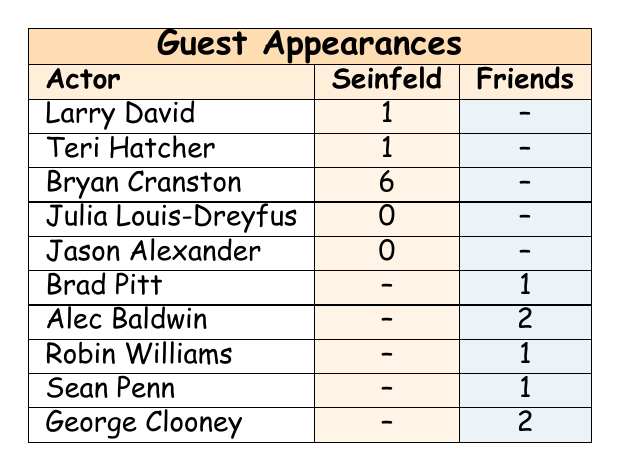What is the total number of guest appearances by Bryan Cranston in "Seinfeld"? Bryan Cranston is listed under the "Seinfeld" column with a total of 6 episodes. The only number next to his name indicates how many episodes he appeared in.
Answer: 6 How many guest appearances did Larry David make in "Seinfeld"? Larry David is also found in the "Seinfeld" column, where it states he appeared in 1 episode.
Answer: 1 Did any actor appear in both "Seinfeld" and "Friends"? By looking at the table, none of the actors listed appear in both columns. The "Seinfeld" actors and the "Friends" actors are distinct.
Answer: No Which show had more guest appearances overall? To determine this, we add up the guest appearances for each show. "Seinfeld" has 6 + 1 + 1 + 0 + 0 = 9 episodes. "Friends" totals 1 + 2 + 1 + 1 + 2 = 7 episodes. Comparing the totals, "Seinfeld" has more guest appearances.
Answer: Seinfeld What is the average number of guest appearances for actors in "Friends"? The total guest appearances in "Friends" is 1 + 2 + 1 + 1 + 2 = 7. There are 5 different actors, so the average is calculated by dividing the total by the number of actors: 7 / 5 = 1.4.
Answer: 1.4 Who had the most guest appearances in "Friends"? Looking through the "Friends" column, Alec Baldwin has 2 appearances, which is more than any other actor listed there.
Answer: Alec Baldwin Is it true that Julia Louis-Dreyfus had guest appearances in "Friends"? The table shows Julia Louis-Dreyfus under "Seinfeld" with 0 episodes and does not mention her under "Friends," meaning she did not appear in it.
Answer: No What is the sum of guest appearances between both shows? The total from "Seinfeld" is 6 + 1 + 1 + 0 + 0 = 9, and for "Friends," it is 1 + 2 + 1 + 1 + 2 = 7. Adding these totals together gives us 9 + 7 = 16 episodes overall.
Answer: 16 Which actor had the least number of guest appearances in "Seinfeld"? In "Seinfeld," both Julia Louis-Dreyfus and Jason Alexander have 0 guest appearances, which are the least. Hence they share this distinction.
Answer: Julia Louis-Dreyfus and Jason Alexander 